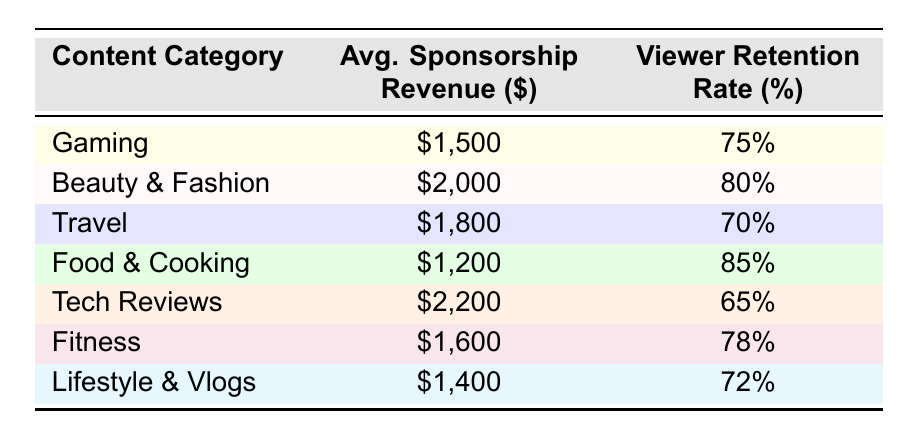What is the average sponsorship revenue for Beauty & Fashion content? From the table, the average sponsorship revenue for Beauty & Fashion is listed as $2,000.
Answer: $2,000 Which content category has the highest viewer retention rate? According to the table, Food & Cooking has the highest viewer retention rate at 85%.
Answer: Food & Cooking What is the difference in average sponsorship revenue between Tech Reviews and Gaming? The average sponsorship revenue for Tech Reviews is $2,200 and for Gaming is $1,500. The difference is $2,200 - $1,500 = $700.
Answer: $700 Is the viewer retention rate for Fitness higher than that for Travel? The viewer retention rate for Fitness is 78% and for Travel is 70%. Since 78% is greater than 70%, it is true.
Answer: Yes What is the average sponsorship revenue for the content categories that have a viewer retention rate above 75%? The categories with retention rates above 75% are Beauty & Fashion (80%), Food & Cooking (85%), and Fitness (78%). Their revenues are $2,000, $1,200, and $1,600 respectively. The average is calculated as (2000 + 1200 + 1600) / 3 = $1,600.
Answer: $1,600 How many categories have a viewer retention rate below 75%? The content categories with viewer retention rates below 75% are Tech Reviews (65%) and Travel (70%). This totals to 2 categories.
Answer: 2 Which content category has the lowest average sponsorship revenue? Upon reviewing the table, Food & Cooking has the lowest average sponsorship revenue at $1,200 compared to others.
Answer: Food & Cooking 